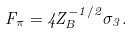<formula> <loc_0><loc_0><loc_500><loc_500>F _ { \pi } = 4 Z ^ { - 1 / 2 } _ { B } \sigma _ { 3 } .</formula> 